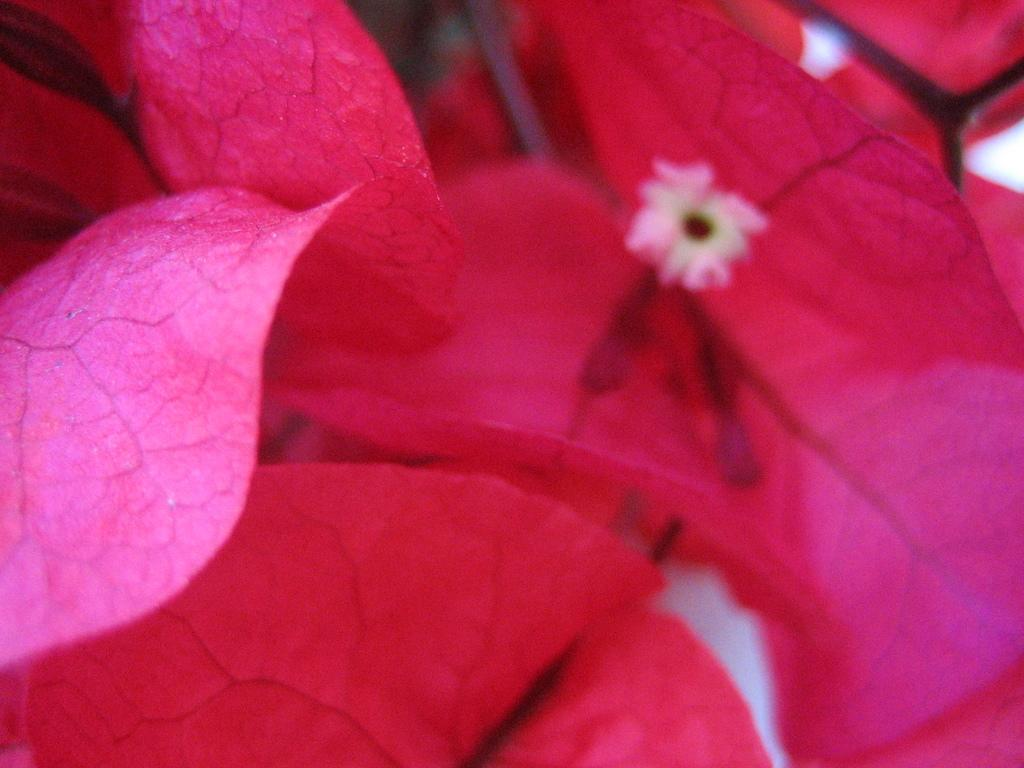What color are the leaves in the image? The leaves in the image are pink. What other floral element can be seen in the image? There is a flower in the image. What type of work is being done on the page in the image? There is no page or work being done in the image; it only features pink leaves and a flower. 